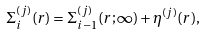<formula> <loc_0><loc_0><loc_500><loc_500>\Sigma _ { i } ^ { ( j ) } ( r ) = \Sigma _ { i - 1 } ^ { ( j ) } ( r ; \infty ) + \eta ^ { ( j ) } ( r ) ,</formula> 